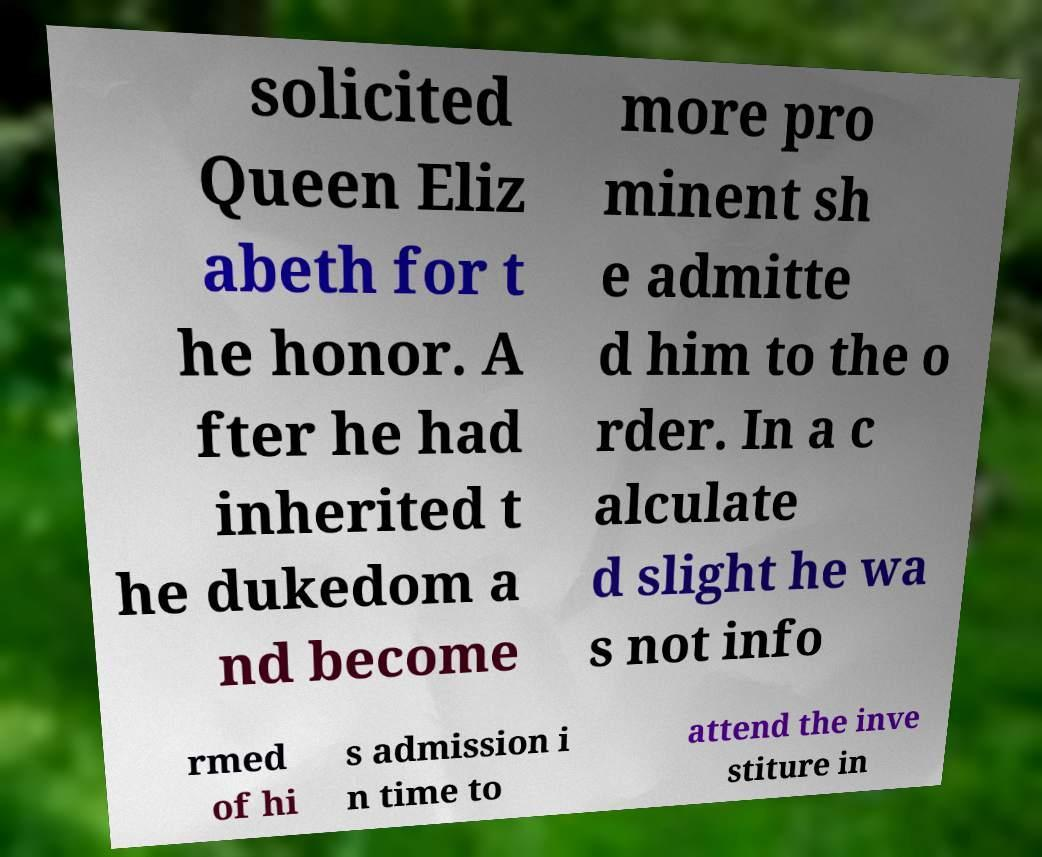For documentation purposes, I need the text within this image transcribed. Could you provide that? solicited Queen Eliz abeth for t he honor. A fter he had inherited t he dukedom a nd become more pro minent sh e admitte d him to the o rder. In a c alculate d slight he wa s not info rmed of hi s admission i n time to attend the inve stiture in 